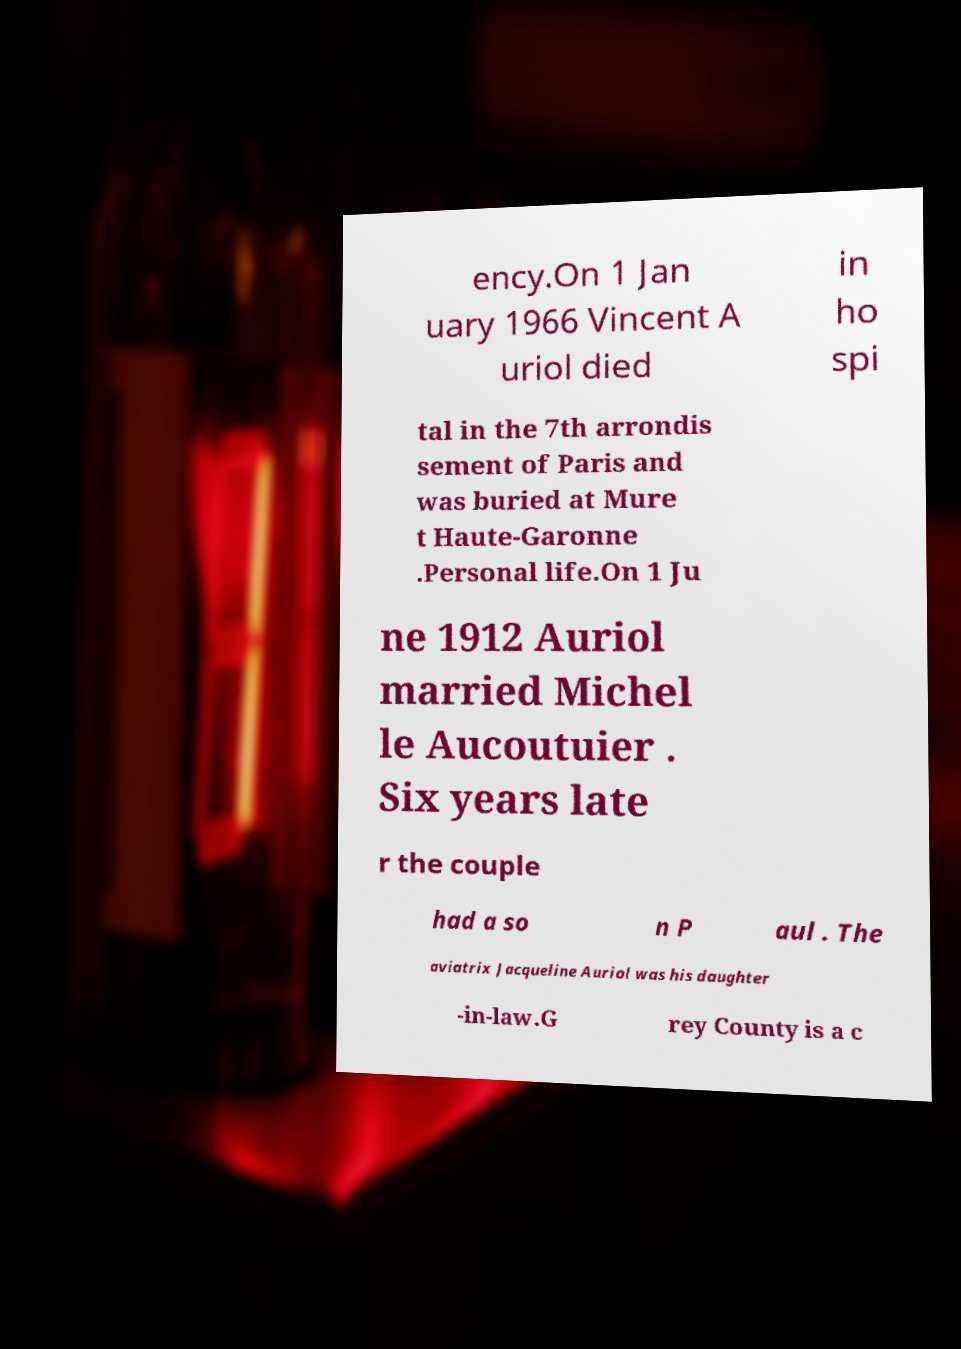Could you assist in decoding the text presented in this image and type it out clearly? ency.On 1 Jan uary 1966 Vincent A uriol died in ho spi tal in the 7th arrondis sement of Paris and was buried at Mure t Haute-Garonne .Personal life.On 1 Ju ne 1912 Auriol married Michel le Aucoutuier . Six years late r the couple had a so n P aul . The aviatrix Jacqueline Auriol was his daughter -in-law.G rey County is a c 